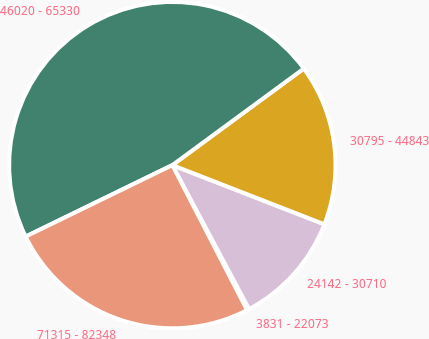<chart> <loc_0><loc_0><loc_500><loc_500><pie_chart><fcel>3831 - 22073<fcel>24142 - 30710<fcel>30795 - 44843<fcel>46020 - 65330<fcel>71315 - 82348<nl><fcel>0.22%<fcel>11.3%<fcel>15.99%<fcel>47.14%<fcel>25.36%<nl></chart> 